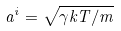<formula> <loc_0><loc_0><loc_500><loc_500>a ^ { i } = \sqrt { \gamma k T / m }</formula> 